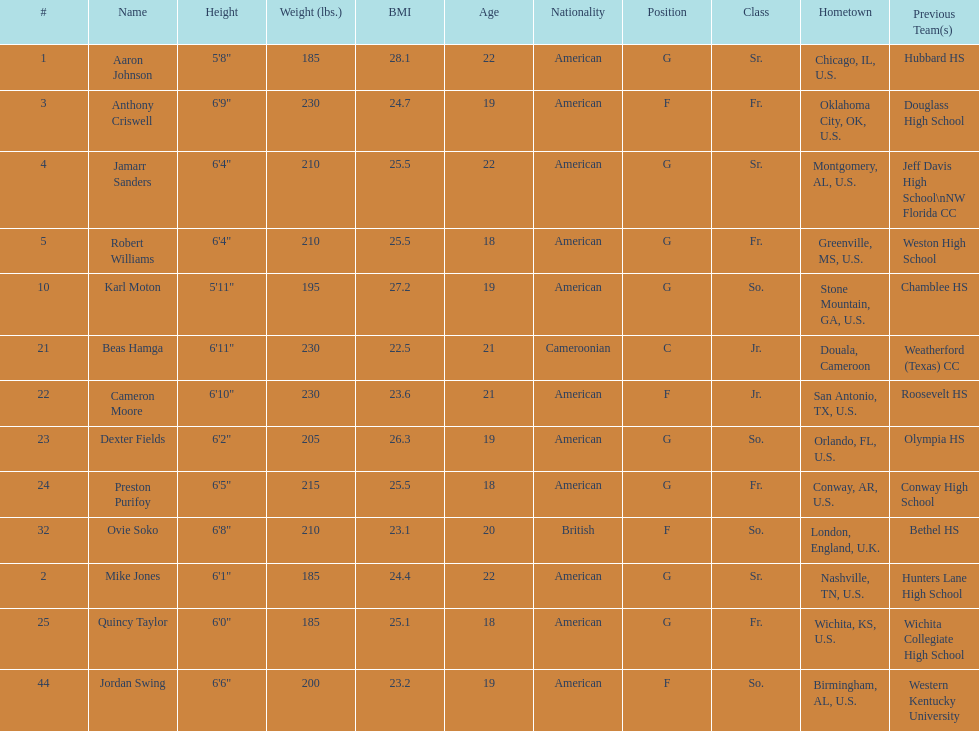What is the difference in weight between dexter fields and quincy taylor? 20. 